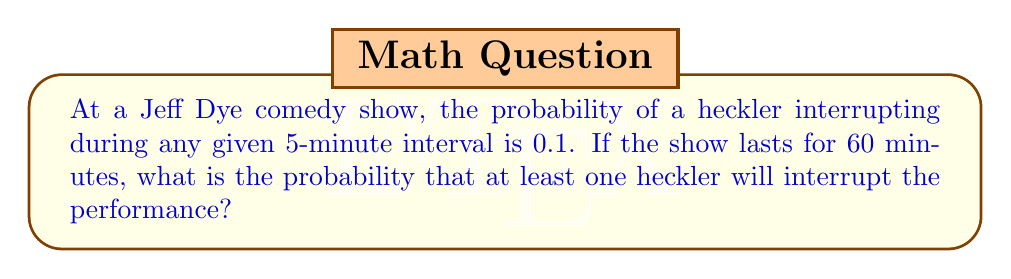Show me your answer to this math problem. Let's approach this step-by-step using a Bernoulli process:

1) First, we need to determine the number of 5-minute intervals in a 60-minute show:
   $n = 60 / 5 = 12$ intervals

2) The probability of a heckler interrupting in any 5-minute interval is $p = 0.1$

3) We want to find the probability of at least one heckler interrupting, which is the opposite of no hecklers interrupting at all.

4) The probability of no hecklers in one interval is $1 - p = 0.9$

5) For no hecklers throughout the entire show, we need this to happen in all 12 intervals. The probability is:

   $P(\text{no hecklers}) = (0.9)^{12}$

6) Therefore, the probability of at least one heckler is:

   $P(\text{at least one heckler}) = 1 - P(\text{no hecklers})$
   
   $= 1 - (0.9)^{12}$

7) Calculating this:
   $1 - (0.9)^{12} = 1 - 0.2824 = 0.7176$

Thus, there's approximately a 71.76% chance of at least one heckler interrupting the show.
Answer: $1 - (0.9)^{12} \approx 0.7176$ 